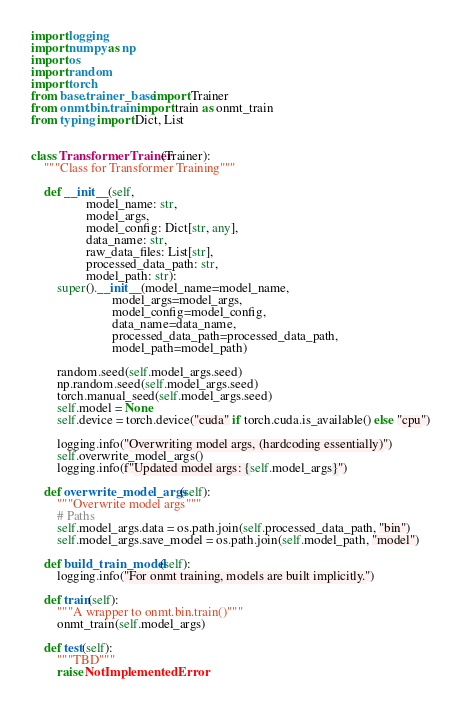<code> <loc_0><loc_0><loc_500><loc_500><_Python_>import logging
import numpy as np
import os
import random
import torch
from base.trainer_base import Trainer
from onmt.bin.train import train as onmt_train
from typing import Dict, List


class TransformerTrainer(Trainer):
    """Class for Transformer Training"""

    def __init__(self,
                 model_name: str,
                 model_args,
                 model_config: Dict[str, any],
                 data_name: str,
                 raw_data_files: List[str],
                 processed_data_path: str,
                 model_path: str):
        super().__init__(model_name=model_name,
                         model_args=model_args,
                         model_config=model_config,
                         data_name=data_name,
                         processed_data_path=processed_data_path,
                         model_path=model_path)

        random.seed(self.model_args.seed)
        np.random.seed(self.model_args.seed)
        torch.manual_seed(self.model_args.seed)
        self.model = None
        self.device = torch.device("cuda" if torch.cuda.is_available() else "cpu")

        logging.info("Overwriting model args, (hardcoding essentially)")
        self.overwrite_model_args()
        logging.info(f"Updated model args: {self.model_args}")

    def overwrite_model_args(self):
        """Overwrite model args"""
        # Paths
        self.model_args.data = os.path.join(self.processed_data_path, "bin")
        self.model_args.save_model = os.path.join(self.model_path, "model")

    def build_train_model(self):
        logging.info("For onmt training, models are built implicitly.")

    def train(self):
        """A wrapper to onmt.bin.train()"""
        onmt_train(self.model_args)

    def test(self):
        """TBD"""
        raise NotImplementedError
</code> 